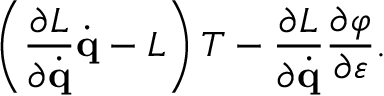<formula> <loc_0><loc_0><loc_500><loc_500>\left ( { \frac { \partial L } { \partial { \dot { q } } } } { \dot { q } } - L \right ) T - { \frac { \partial L } { \partial { \dot { q } } } } { \frac { \partial \varphi } { \partial \varepsilon } } .</formula> 